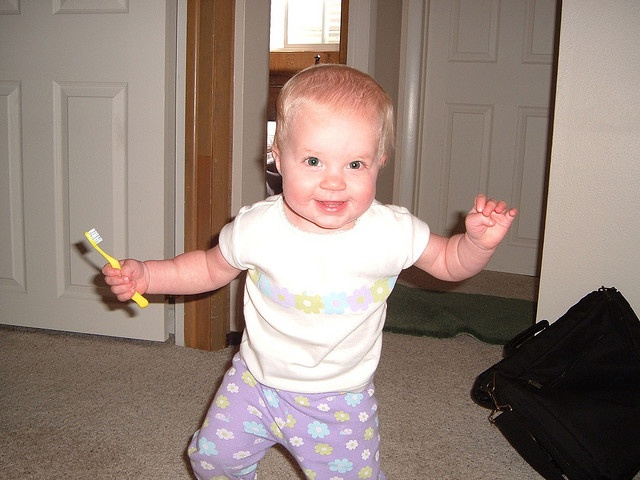Describe the objects in this image and their specific colors. I can see people in gray, white, lightpink, and lavender tones, handbag in gray, black, and darkgray tones, and toothbrush in gray, khaki, white, and tan tones in this image. 